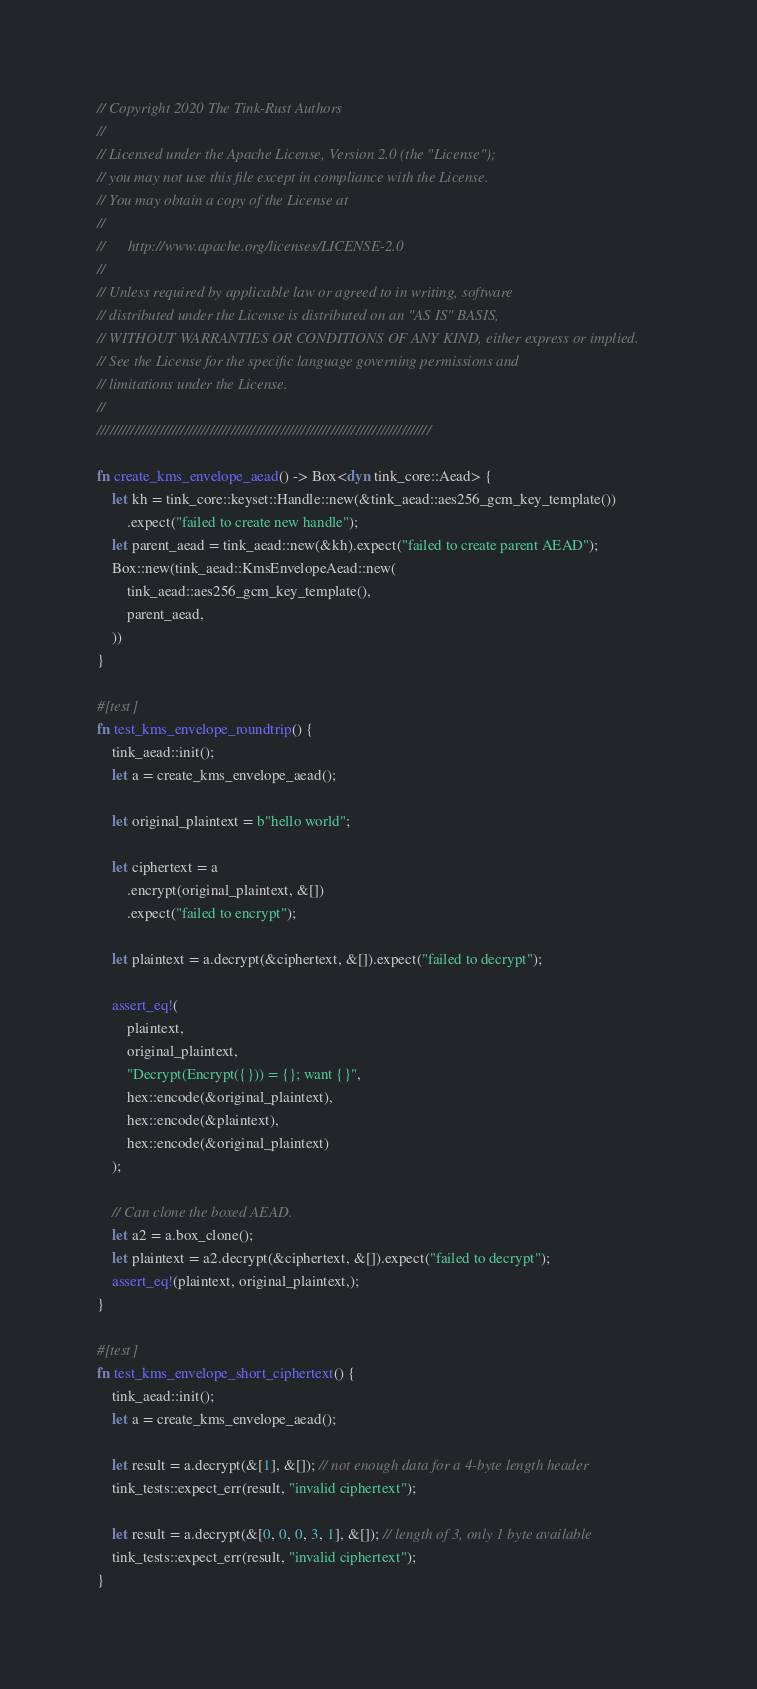<code> <loc_0><loc_0><loc_500><loc_500><_Rust_>// Copyright 2020 The Tink-Rust Authors
//
// Licensed under the Apache License, Version 2.0 (the "License");
// you may not use this file except in compliance with the License.
// You may obtain a copy of the License at
//
//      http://www.apache.org/licenses/LICENSE-2.0
//
// Unless required by applicable law or agreed to in writing, software
// distributed under the License is distributed on an "AS IS" BASIS,
// WITHOUT WARRANTIES OR CONDITIONS OF ANY KIND, either express or implied.
// See the License for the specific language governing permissions and
// limitations under the License.
//
////////////////////////////////////////////////////////////////////////////////

fn create_kms_envelope_aead() -> Box<dyn tink_core::Aead> {
    let kh = tink_core::keyset::Handle::new(&tink_aead::aes256_gcm_key_template())
        .expect("failed to create new handle");
    let parent_aead = tink_aead::new(&kh).expect("failed to create parent AEAD");
    Box::new(tink_aead::KmsEnvelopeAead::new(
        tink_aead::aes256_gcm_key_template(),
        parent_aead,
    ))
}

#[test]
fn test_kms_envelope_roundtrip() {
    tink_aead::init();
    let a = create_kms_envelope_aead();

    let original_plaintext = b"hello world";

    let ciphertext = a
        .encrypt(original_plaintext, &[])
        .expect("failed to encrypt");

    let plaintext = a.decrypt(&ciphertext, &[]).expect("failed to decrypt");

    assert_eq!(
        plaintext,
        original_plaintext,
        "Decrypt(Encrypt({})) = {}; want {}",
        hex::encode(&original_plaintext),
        hex::encode(&plaintext),
        hex::encode(&original_plaintext)
    );

    // Can clone the boxed AEAD.
    let a2 = a.box_clone();
    let plaintext = a2.decrypt(&ciphertext, &[]).expect("failed to decrypt");
    assert_eq!(plaintext, original_plaintext,);
}

#[test]
fn test_kms_envelope_short_ciphertext() {
    tink_aead::init();
    let a = create_kms_envelope_aead();

    let result = a.decrypt(&[1], &[]); // not enough data for a 4-byte length header
    tink_tests::expect_err(result, "invalid ciphertext");

    let result = a.decrypt(&[0, 0, 0, 3, 1], &[]); // length of 3, only 1 byte available
    tink_tests::expect_err(result, "invalid ciphertext");
}
</code> 